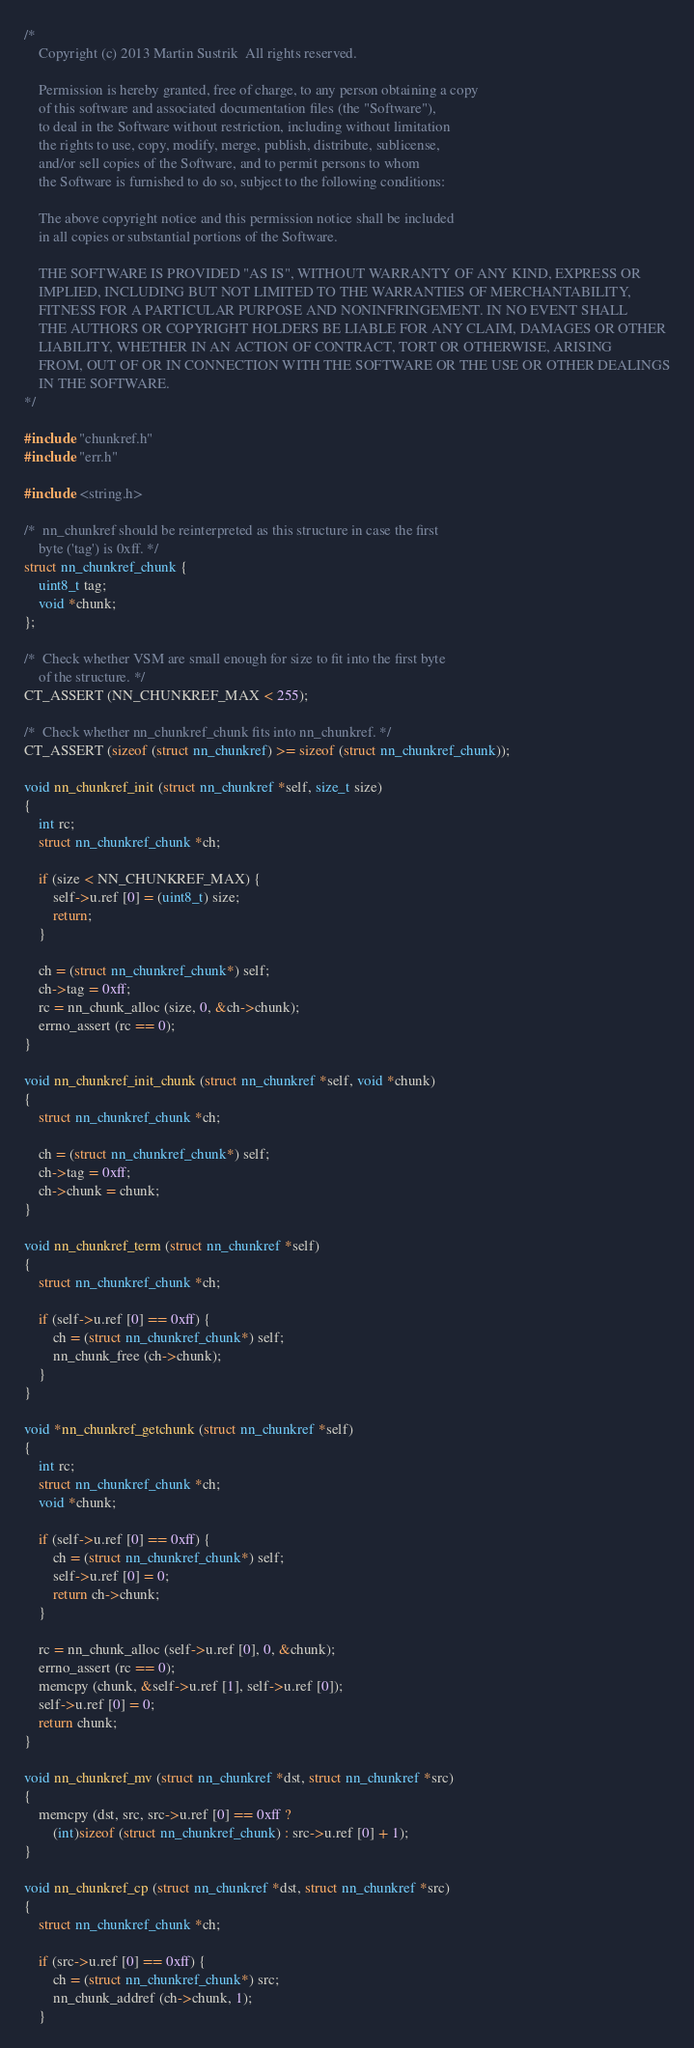<code> <loc_0><loc_0><loc_500><loc_500><_C_>/*
    Copyright (c) 2013 Martin Sustrik  All rights reserved.

    Permission is hereby granted, free of charge, to any person obtaining a copy
    of this software and associated documentation files (the "Software"),
    to deal in the Software without restriction, including without limitation
    the rights to use, copy, modify, merge, publish, distribute, sublicense,
    and/or sell copies of the Software, and to permit persons to whom
    the Software is furnished to do so, subject to the following conditions:

    The above copyright notice and this permission notice shall be included
    in all copies or substantial portions of the Software.

    THE SOFTWARE IS PROVIDED "AS IS", WITHOUT WARRANTY OF ANY KIND, EXPRESS OR
    IMPLIED, INCLUDING BUT NOT LIMITED TO THE WARRANTIES OF MERCHANTABILITY,
    FITNESS FOR A PARTICULAR PURPOSE AND NONINFRINGEMENT. IN NO EVENT SHALL
    THE AUTHORS OR COPYRIGHT HOLDERS BE LIABLE FOR ANY CLAIM, DAMAGES OR OTHER
    LIABILITY, WHETHER IN AN ACTION OF CONTRACT, TORT OR OTHERWISE, ARISING
    FROM, OUT OF OR IN CONNECTION WITH THE SOFTWARE OR THE USE OR OTHER DEALINGS
    IN THE SOFTWARE.
*/

#include "chunkref.h"
#include "err.h"

#include <string.h>

/*  nn_chunkref should be reinterpreted as this structure in case the first
    byte ('tag') is 0xff. */
struct nn_chunkref_chunk {
    uint8_t tag;
    void *chunk;
};

/*  Check whether VSM are small enough for size to fit into the first byte
    of the structure. */
CT_ASSERT (NN_CHUNKREF_MAX < 255);

/*  Check whether nn_chunkref_chunk fits into nn_chunkref. */
CT_ASSERT (sizeof (struct nn_chunkref) >= sizeof (struct nn_chunkref_chunk));

void nn_chunkref_init (struct nn_chunkref *self, size_t size)
{
    int rc;
    struct nn_chunkref_chunk *ch;

    if (size < NN_CHUNKREF_MAX) {
        self->u.ref [0] = (uint8_t) size;
        return;
    }

    ch = (struct nn_chunkref_chunk*) self;
    ch->tag = 0xff;
    rc = nn_chunk_alloc (size, 0, &ch->chunk);
    errno_assert (rc == 0);
}

void nn_chunkref_init_chunk (struct nn_chunkref *self, void *chunk)
{
    struct nn_chunkref_chunk *ch;

    ch = (struct nn_chunkref_chunk*) self;
    ch->tag = 0xff;
    ch->chunk = chunk;
}

void nn_chunkref_term (struct nn_chunkref *self)
{
    struct nn_chunkref_chunk *ch;

    if (self->u.ref [0] == 0xff) {
        ch = (struct nn_chunkref_chunk*) self;
        nn_chunk_free (ch->chunk);
    }
}

void *nn_chunkref_getchunk (struct nn_chunkref *self)
{
    int rc;
    struct nn_chunkref_chunk *ch;
    void *chunk;

    if (self->u.ref [0] == 0xff) {
        ch = (struct nn_chunkref_chunk*) self;
        self->u.ref [0] = 0;
        return ch->chunk;
    }

    rc = nn_chunk_alloc (self->u.ref [0], 0, &chunk);
    errno_assert (rc == 0);
    memcpy (chunk, &self->u.ref [1], self->u.ref [0]);
    self->u.ref [0] = 0;
    return chunk;
}

void nn_chunkref_mv (struct nn_chunkref *dst, struct nn_chunkref *src)
{
    memcpy (dst, src, src->u.ref [0] == 0xff ?
        (int)sizeof (struct nn_chunkref_chunk) : src->u.ref [0] + 1);
}

void nn_chunkref_cp (struct nn_chunkref *dst, struct nn_chunkref *src)
{
    struct nn_chunkref_chunk *ch;

    if (src->u.ref [0] == 0xff) {
        ch = (struct nn_chunkref_chunk*) src;
        nn_chunk_addref (ch->chunk, 1);
    }</code> 